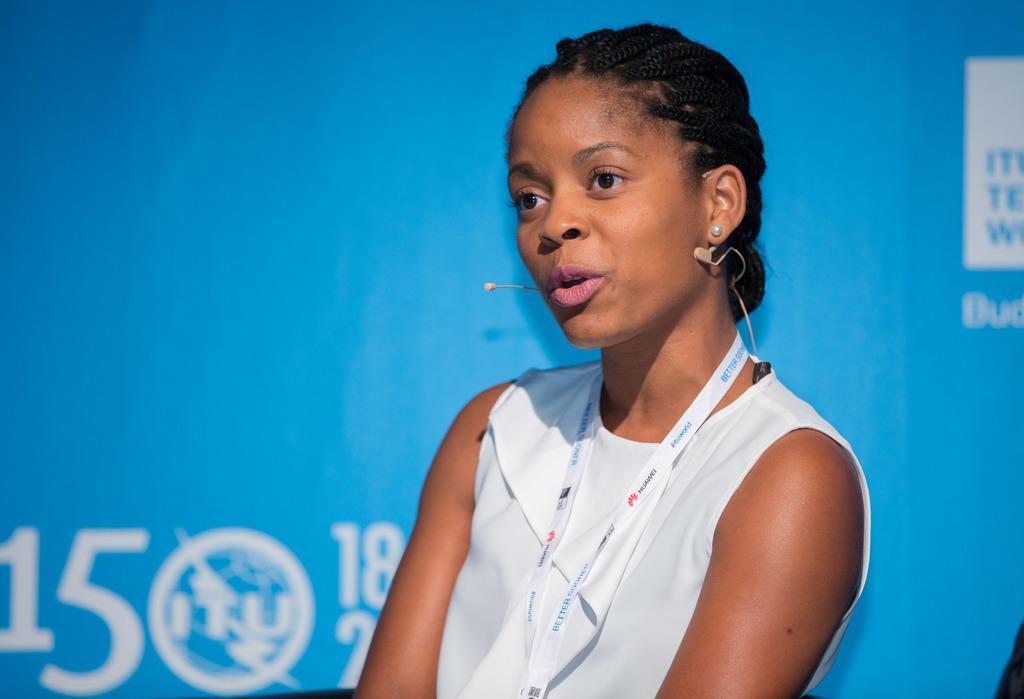In one or two sentences, can you explain what this image depicts? In this image I can see a person wearing white color dress and background I can see a board in blue color and I can see something with white color on the board. 